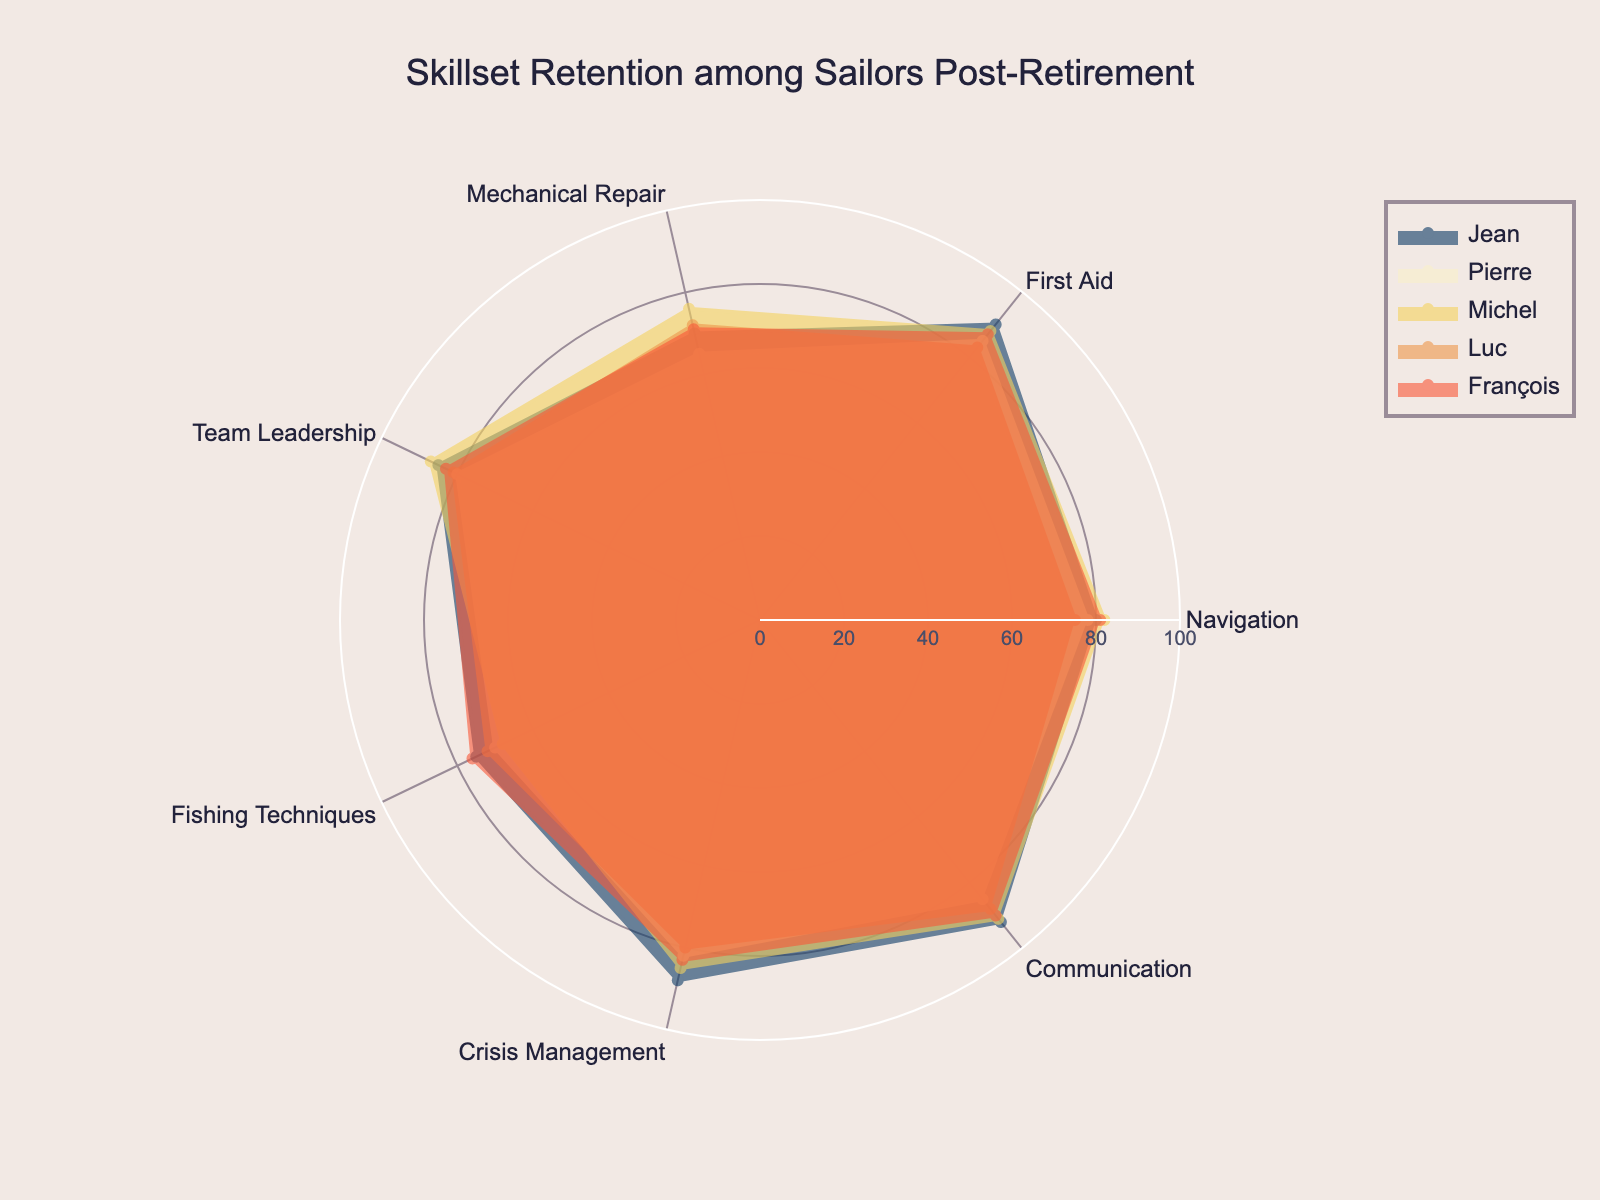What is the title of the radar chart? The title is displayed prominently at the top of the chart. This information can be directly read without any calculation.
Answer: Skillset Retention among Sailors Post-Retirement How many skills are assessed in this radar chart? The chart displays each sailor's data across different axes, each representing a skill. By counting these axes, we can determine the total number of skills assessed.
Answer: 7 Which sailor has the highest score in Communication? Locate the "Communication" axis and compare the positions of the data points for each sailor to find the highest value.
Answer: Jean What is the average score of François in all the assessed skills? Add François' scores in all skills and divide by the number of skills. Thus, (81 + 87 + 71 + 83 + 76 + 83 + 90)/7 equals approximately 81.6.
Answer: 81.6 Who has a higher score in Mechanical Repair, Luc or Michel? Look at the "Mechanical Repair" axis and compare the scores of Luc and Michel directly. Luc has a score of 72 and Michel has 76.
Answer: Michel What is the range of values for Navigation among all sailors? Identify the maximum and minimum scores on the "Navigation" axis. The highest score is 82 (Michel) and the lowest is 75 (Luc), so the range is 82 - 75.
Answer: 7 Which two sailors have the most similar scores in Team Leadership? Compare the distances from the center on the "Team Leadership" axis for all sailors. Jean (85) and Michel (87) have the most similar scores, with a difference of 2.
Answer: Jean and Michel What is Jean's total score across all skills? Sum Jean’s scores in all skills: 80 + 90 + 70 + 85 + 75 + 88 + 92 = 580.
Answer: 580 Which sailor shows the least skill retention in Fishing Techniques? Locate the "Fishing Techniques" axis and determine which sailor has the lowest score. Michel has the lowest score of 68.
Answer: Michel Is there any skill in which all sailors score above 80? Examine each axis to see if all data points (representing sailors) lie above the 80 marks. For "Communication," all sailors score at least 85.
Answer: Communication 